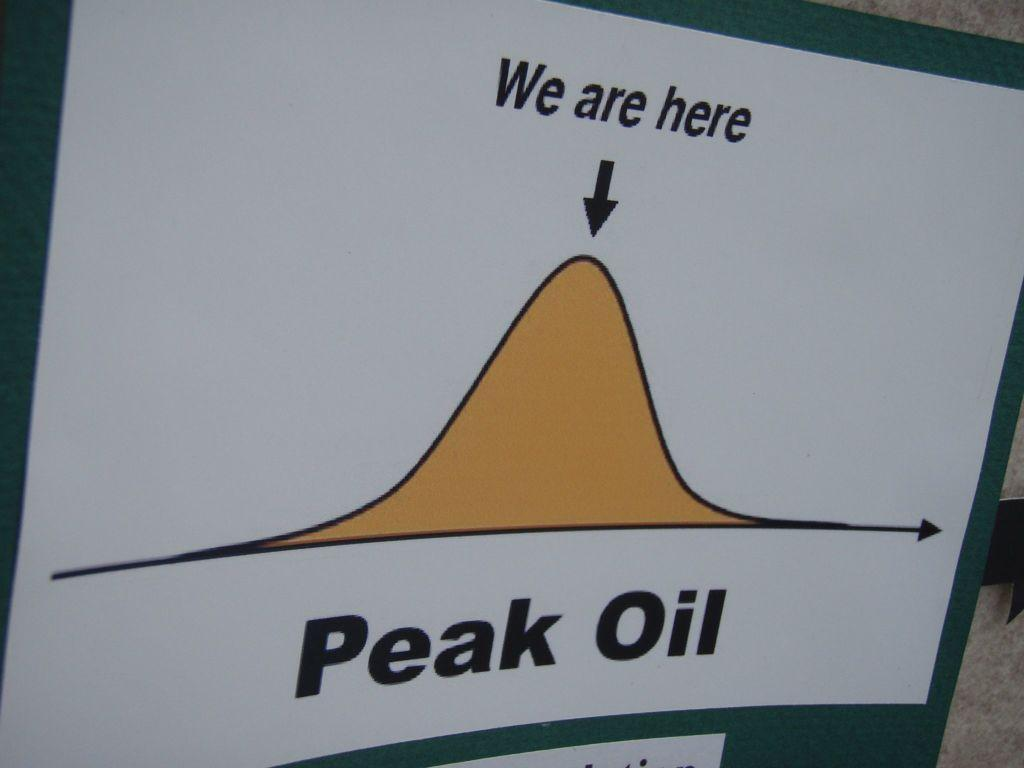Provide a one-sentence caption for the provided image. The bell curve diagram showed where the company was ranked. 